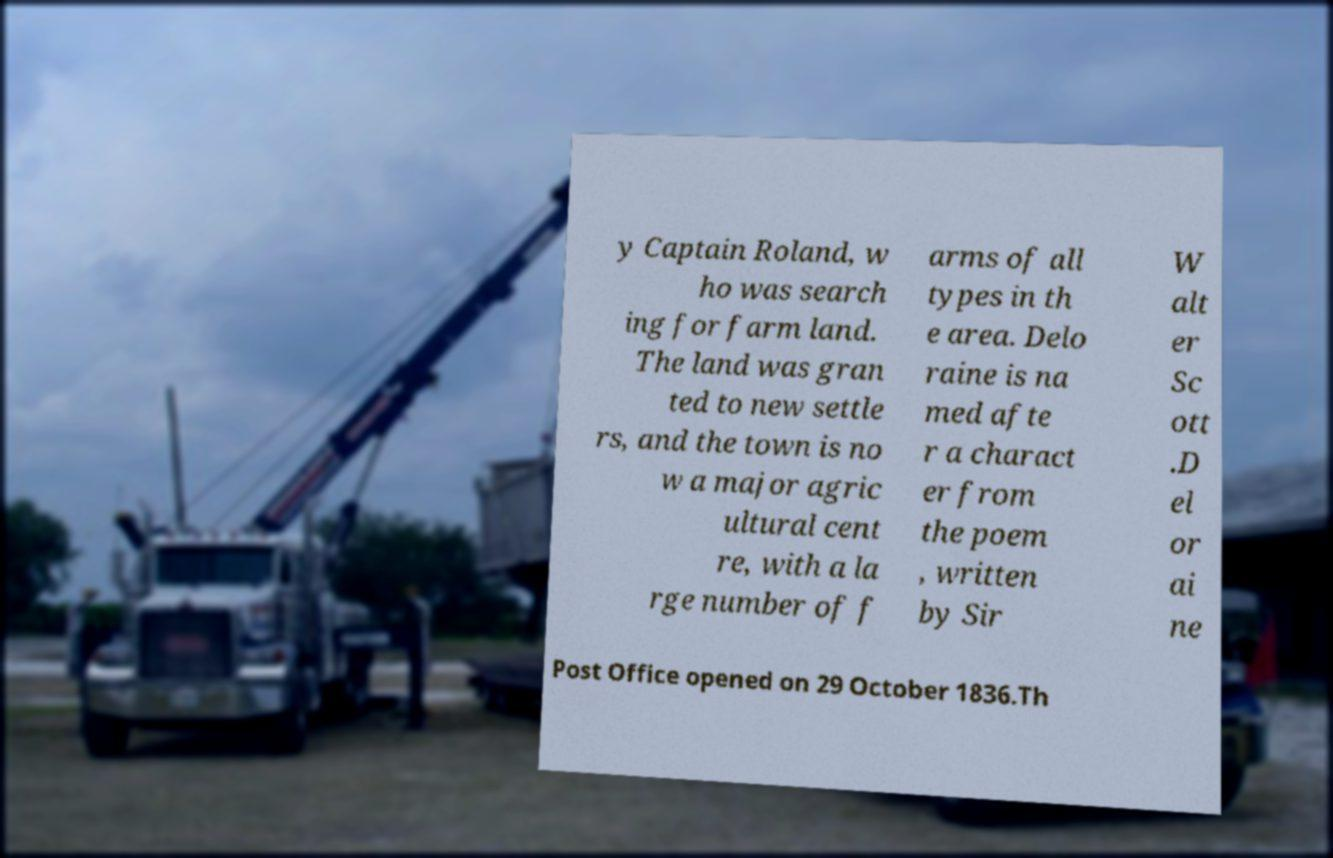Please identify and transcribe the text found in this image. y Captain Roland, w ho was search ing for farm land. The land was gran ted to new settle rs, and the town is no w a major agric ultural cent re, with a la rge number of f arms of all types in th e area. Delo raine is na med afte r a charact er from the poem , written by Sir W alt er Sc ott .D el or ai ne Post Office opened on 29 October 1836.Th 